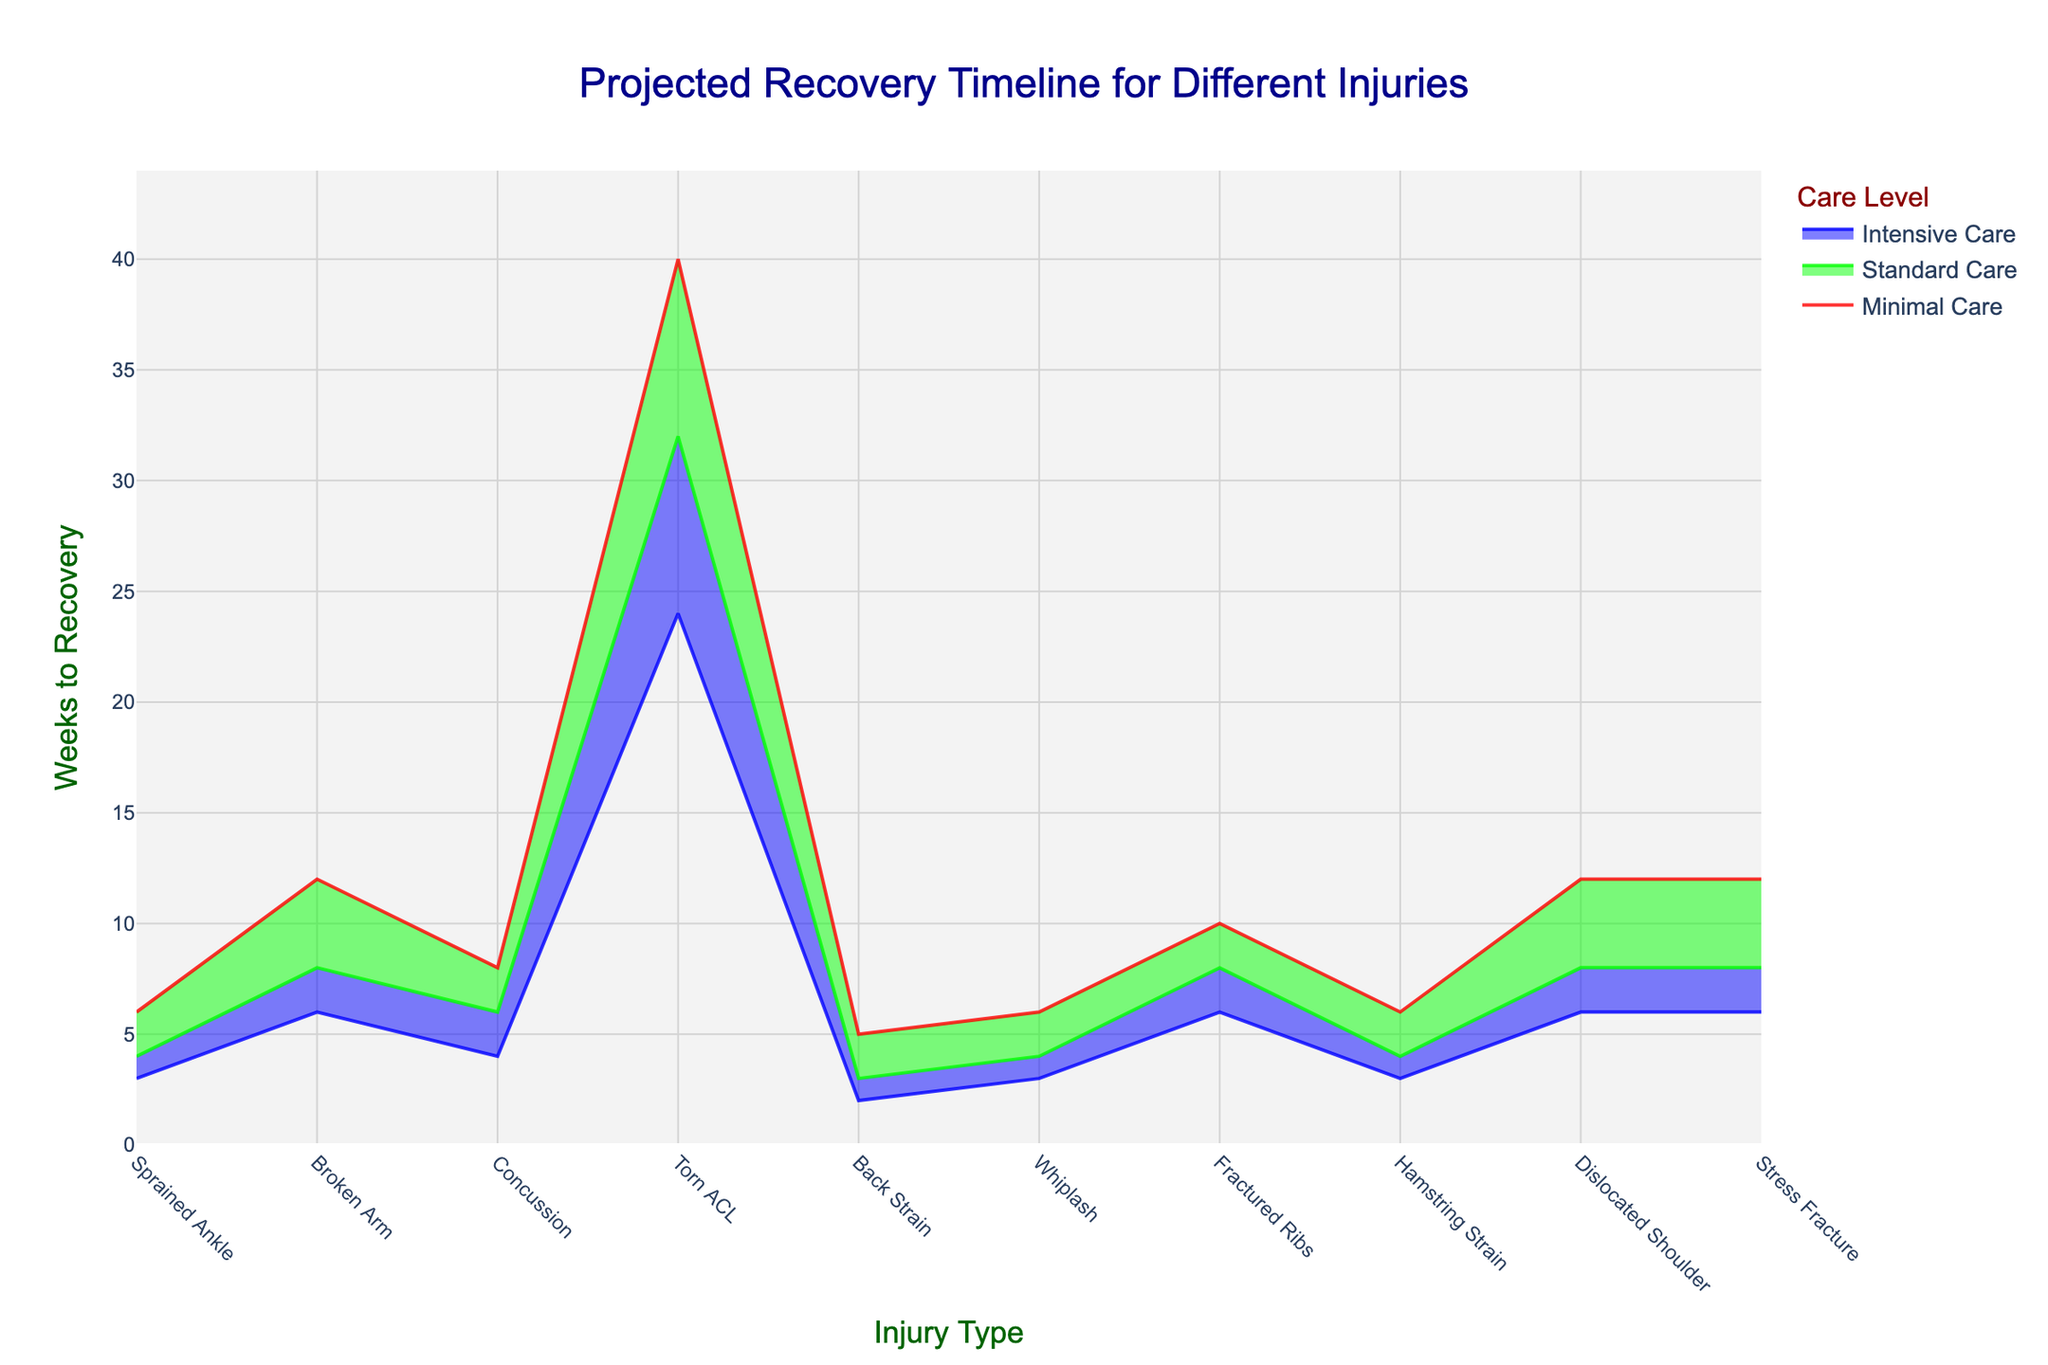What is the title of the chart? The title is displayed at the top center of the chart. It reads 'Projected Recovery Timeline for Different Injuries'.
Answer: Projected Recovery Timeline for Different Injuries Which injury type requires the least recovery time with intensive care? Intensive care recovery times are represented by the lowest line in the chart, which is blue. The points at their lowest on this line correspond to Back Strain and Hamstring Strain.
Answer: Back Strain and Hamstring Strain How many weeks does a sprained ankle take to recover with standard care? Locate the "Sprained Ankle" label on the horizontal axis, then refer to the green line representing standard care. The value is 4 weeks.
Answer: 4 weeks What is the difference in recovery time between minimal and intensive care for a Torn ACL? Locate the Torn ACL on the horizontal axis, then note the recovery times for minimal care (40 weeks) and intensive care (24 weeks). The difference is 40 - 24.
Answer: 16 weeks Which type of care results in the longest recovery time for any injury? The line representing minimal care (red) generally shows the highest values, indicating the longest recovery time. The highest value on this line is for Torn ACL.
Answer: Minimal care Compare the recovery times for a broken arm with standard care versus intensive care. Locate the "Broken Arm" on the horizontal axis. For standard care, the green line indicates 8 weeks. For intensive care, the blue line indicates 6 weeks. 8 weeks is greater than 6 weeks.
Answer: Standard care takes longer than intensive care How long is the standard recovery time for a concussion? Locate "Concussion" on the horizontal axis. Follow the green line upward to see the recovery time for standard care, which is 6 weeks.
Answer: 6 weeks What is the average recovery time for a dislocated shoulder across all care levels? Find the dislocated shoulder's recovery times: 12 weeks (minimal care), 8 weeks (standard care), and 6 weeks (intensive care). The average is calculated as (12 + 8 + 6) / 3.
Answer: 8.67 weeks Which injury type shows the greatest range in recovery times across all care levels? Calculate the range for each injury: Torn ACL has 40 weeks (minimal) - 24 weeks (intensive) = 16 weeks, which is the highest among all injuries.
Answer: Torn ACL Does a stress fracture or a fractured rib take longer to recover with minimal care? Compare the minimal care times for Stress Fracture and Fractured Ribs. Both show 12 weeks, so they take the same amount of time.
Answer: They take the same amount of time 